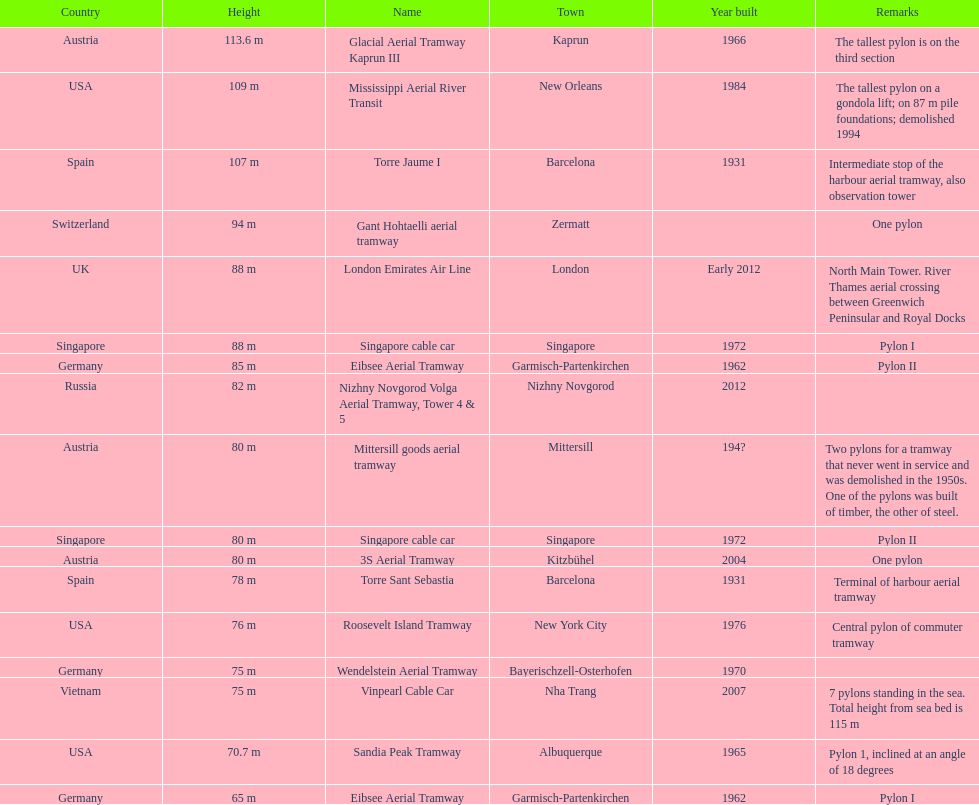Could you help me parse every detail presented in this table? {'header': ['Country', 'Height', 'Name', 'Town', 'Year built', 'Remarks'], 'rows': [['Austria', '113.6 m', 'Glacial Aerial Tramway Kaprun III', 'Kaprun', '1966', 'The tallest pylon is on the third section'], ['USA', '109 m', 'Mississippi Aerial River Transit', 'New Orleans', '1984', 'The tallest pylon on a gondola lift; on 87 m pile foundations; demolished 1994'], ['Spain', '107 m', 'Torre Jaume I', 'Barcelona', '1931', 'Intermediate stop of the harbour aerial tramway, also observation tower'], ['Switzerland', '94 m', 'Gant Hohtaelli aerial tramway', 'Zermatt', '', 'One pylon'], ['UK', '88 m', 'London Emirates Air Line', 'London', 'Early 2012', 'North Main Tower. River Thames aerial crossing between Greenwich Peninsular and Royal Docks'], ['Singapore', '88 m', 'Singapore cable car', 'Singapore', '1972', 'Pylon I'], ['Germany', '85 m', 'Eibsee Aerial Tramway', 'Garmisch-Partenkirchen', '1962', 'Pylon II'], ['Russia', '82 m', 'Nizhny Novgorod Volga Aerial Tramway, Tower 4 & 5', 'Nizhny Novgorod', '2012', ''], ['Austria', '80 m', 'Mittersill goods aerial tramway', 'Mittersill', '194?', 'Two pylons for a tramway that never went in service and was demolished in the 1950s. One of the pylons was built of timber, the other of steel.'], ['Singapore', '80 m', 'Singapore cable car', 'Singapore', '1972', 'Pylon II'], ['Austria', '80 m', '3S Aerial Tramway', 'Kitzbühel', '2004', 'One pylon'], ['Spain', '78 m', 'Torre Sant Sebastia', 'Barcelona', '1931', 'Terminal of harbour aerial tramway'], ['USA', '76 m', 'Roosevelt Island Tramway', 'New York City', '1976', 'Central pylon of commuter tramway'], ['Germany', '75 m', 'Wendelstein Aerial Tramway', 'Bayerischzell-Osterhofen', '1970', ''], ['Vietnam', '75 m', 'Vinpearl Cable Car', 'Nha Trang', '2007', '7 pylons standing in the sea. Total height from sea bed is 115 m'], ['USA', '70.7 m', 'Sandia Peak Tramway', 'Albuquerque', '1965', 'Pylon 1, inclined at an angle of 18 degrees'], ['Germany', '65 m', 'Eibsee Aerial Tramway', 'Garmisch-Partenkirchen', '1962', 'Pylon I']]} In what year was germany's final pylon constructed? 1970. 